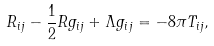Convert formula to latex. <formula><loc_0><loc_0><loc_500><loc_500>R _ { i j } - \frac { 1 } { 2 } R g _ { i j } + \Lambda g _ { i j } = - 8 \pi T _ { i j } ,</formula> 